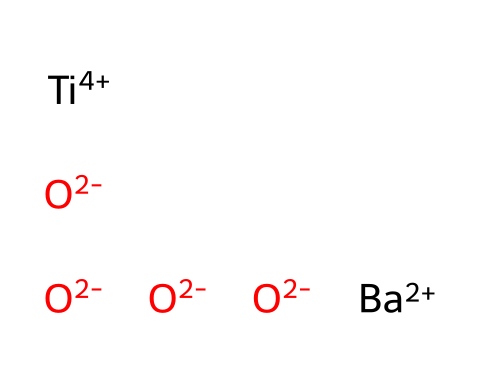how many different atoms are present in this chemical? In the given SMILES representation, there are four distinct atoms: Barium (Ba), Titanium (Ti), and Oxygen (O). Each atom is represented in the structure, and by counting them, we confirm the distinct types.
Answer: three what is the oxidation state of titanium in this chemical? The SMILES notation specifies Titanium (Ti) with a +4 charge, indicating its oxidation state is +4. This charge is explicitly shown, confirming the oxidation state.
Answer: +4 how many oxygen atoms are involved in barium titanate? From the SMILES representation, we can see four oxygen atoms connected to the Barium and Titanium atoms, directly indicating their count.
Answer: four what type of bonding exists in barium titanate? The chemical structure shows ionic interactions between Ba and O (barium oxide), and covalent character associated with Ti and O. This indicates mixed ionic-covalent bonding typical for ceramics.
Answer: mixed ionic-covalent how does the presence of titanium influence the properties of barium titanate? Titanium in this chemical contributes to the ferroelectric properties, which are crucial for materials used in capacitors. The +4 oxidation state allows Ti to bond effectively with oxygen, crucial for the dielectric properties required in electronic circuits.
Answer: ferroelectric properties what role do the oxygen atoms play in the structure of barium titanate? The oxygen atoms form the network and stabilize the structure through bonds with both barium and titanium. They are essential for maintaining the dielectric properties and structural integrity of the material used in capacitors.
Answer: stabilize the structure what is the main application of barium titanate in electronics? Barium titanate is primarily utilized in ceramic capacitors due to its high dielectric constant, which is a crucial property for energy storage in electronic circuits.
Answer: ceramic capacitors 